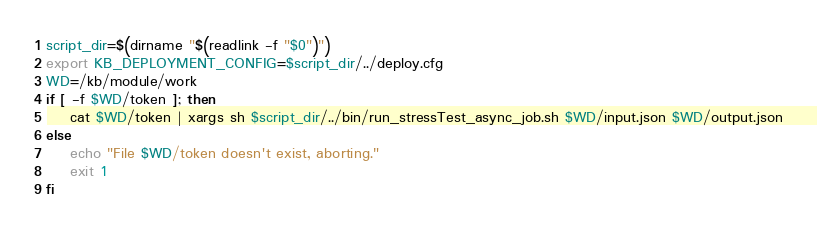<code> <loc_0><loc_0><loc_500><loc_500><_Bash_>script_dir=$(dirname "$(readlink -f "$0")")
export KB_DEPLOYMENT_CONFIG=$script_dir/../deploy.cfg
WD=/kb/module/work
if [ -f $WD/token ]; then
    cat $WD/token | xargs sh $script_dir/../bin/run_stressTest_async_job.sh $WD/input.json $WD/output.json
else
    echo "File $WD/token doesn't exist, aborting."
    exit 1
fi
</code> 